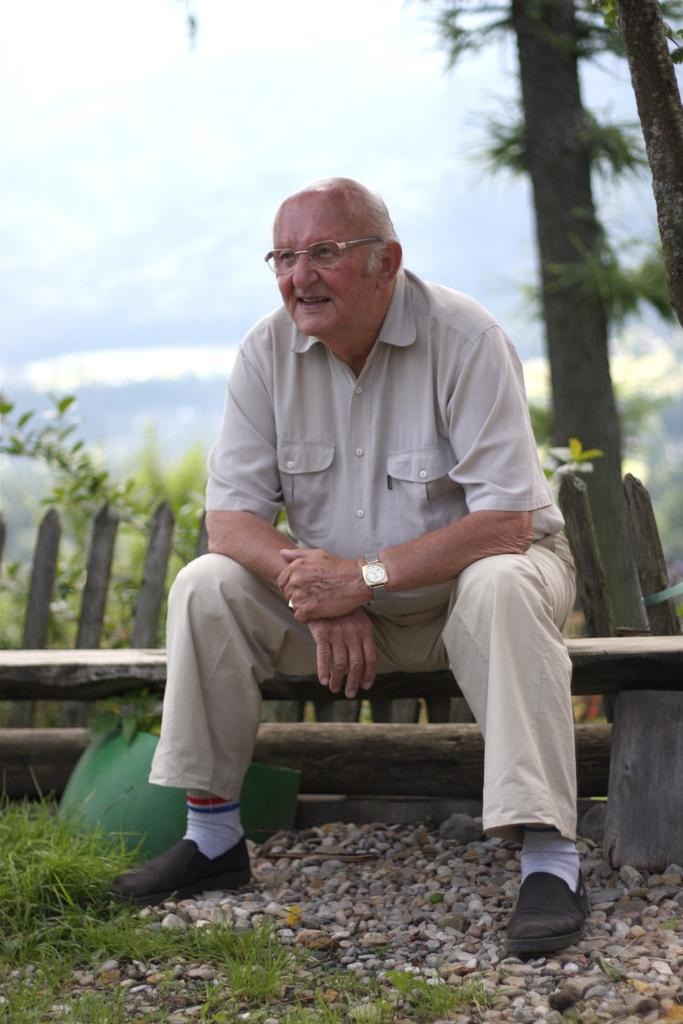What is the main subject of the image? There is a person in the image. What accessories is the person wearing? The person is wearing a watch and glasses (specs). What is the person doing in the image? The person is sitting on a bench. What type of ground is visible in the image? There is grass and stones on the ground. What can be seen in the background of the image? There is a fencing, trees, and the sky visible in the background. Can you tell me how many sails are visible in the image? There are no sails present in the image. What type of goose is sitting next to the person in the image? There is no goose present in the image. 